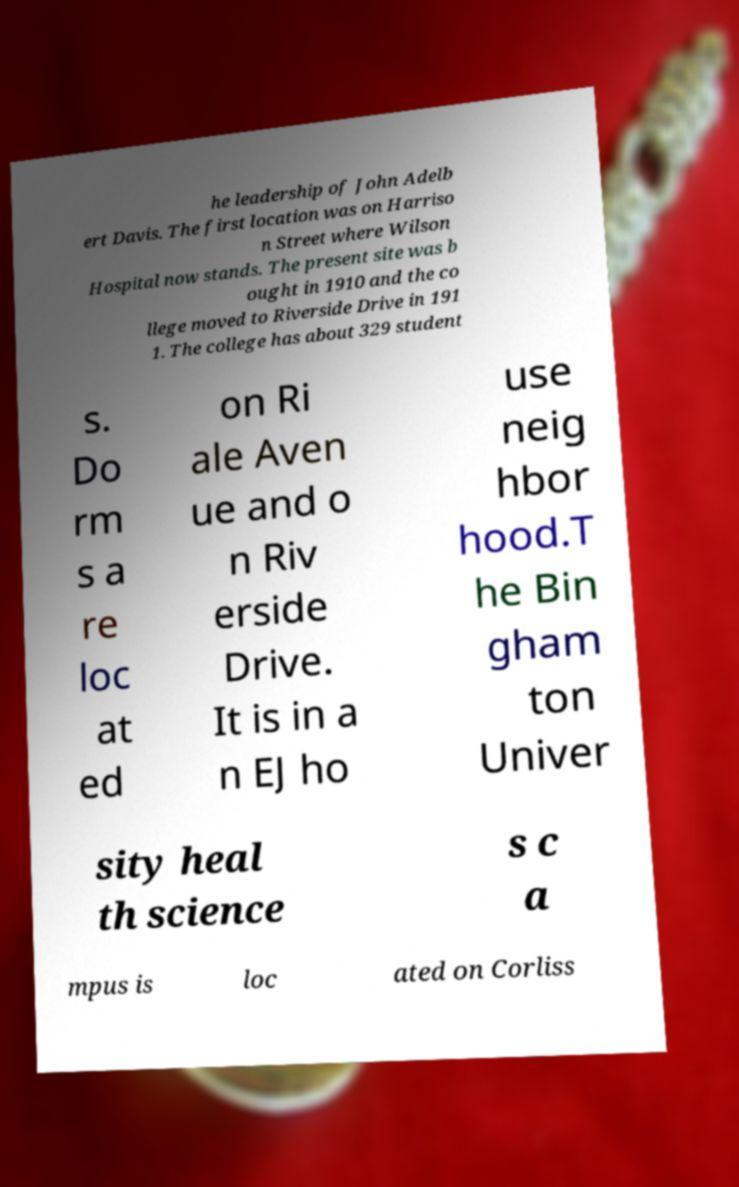Please identify and transcribe the text found in this image. he leadership of John Adelb ert Davis. The first location was on Harriso n Street where Wilson Hospital now stands. The present site was b ought in 1910 and the co llege moved to Riverside Drive in 191 1. The college has about 329 student s. Do rm s a re loc at ed on Ri ale Aven ue and o n Riv erside Drive. It is in a n EJ ho use neig hbor hood.T he Bin gham ton Univer sity heal th science s c a mpus is loc ated on Corliss 